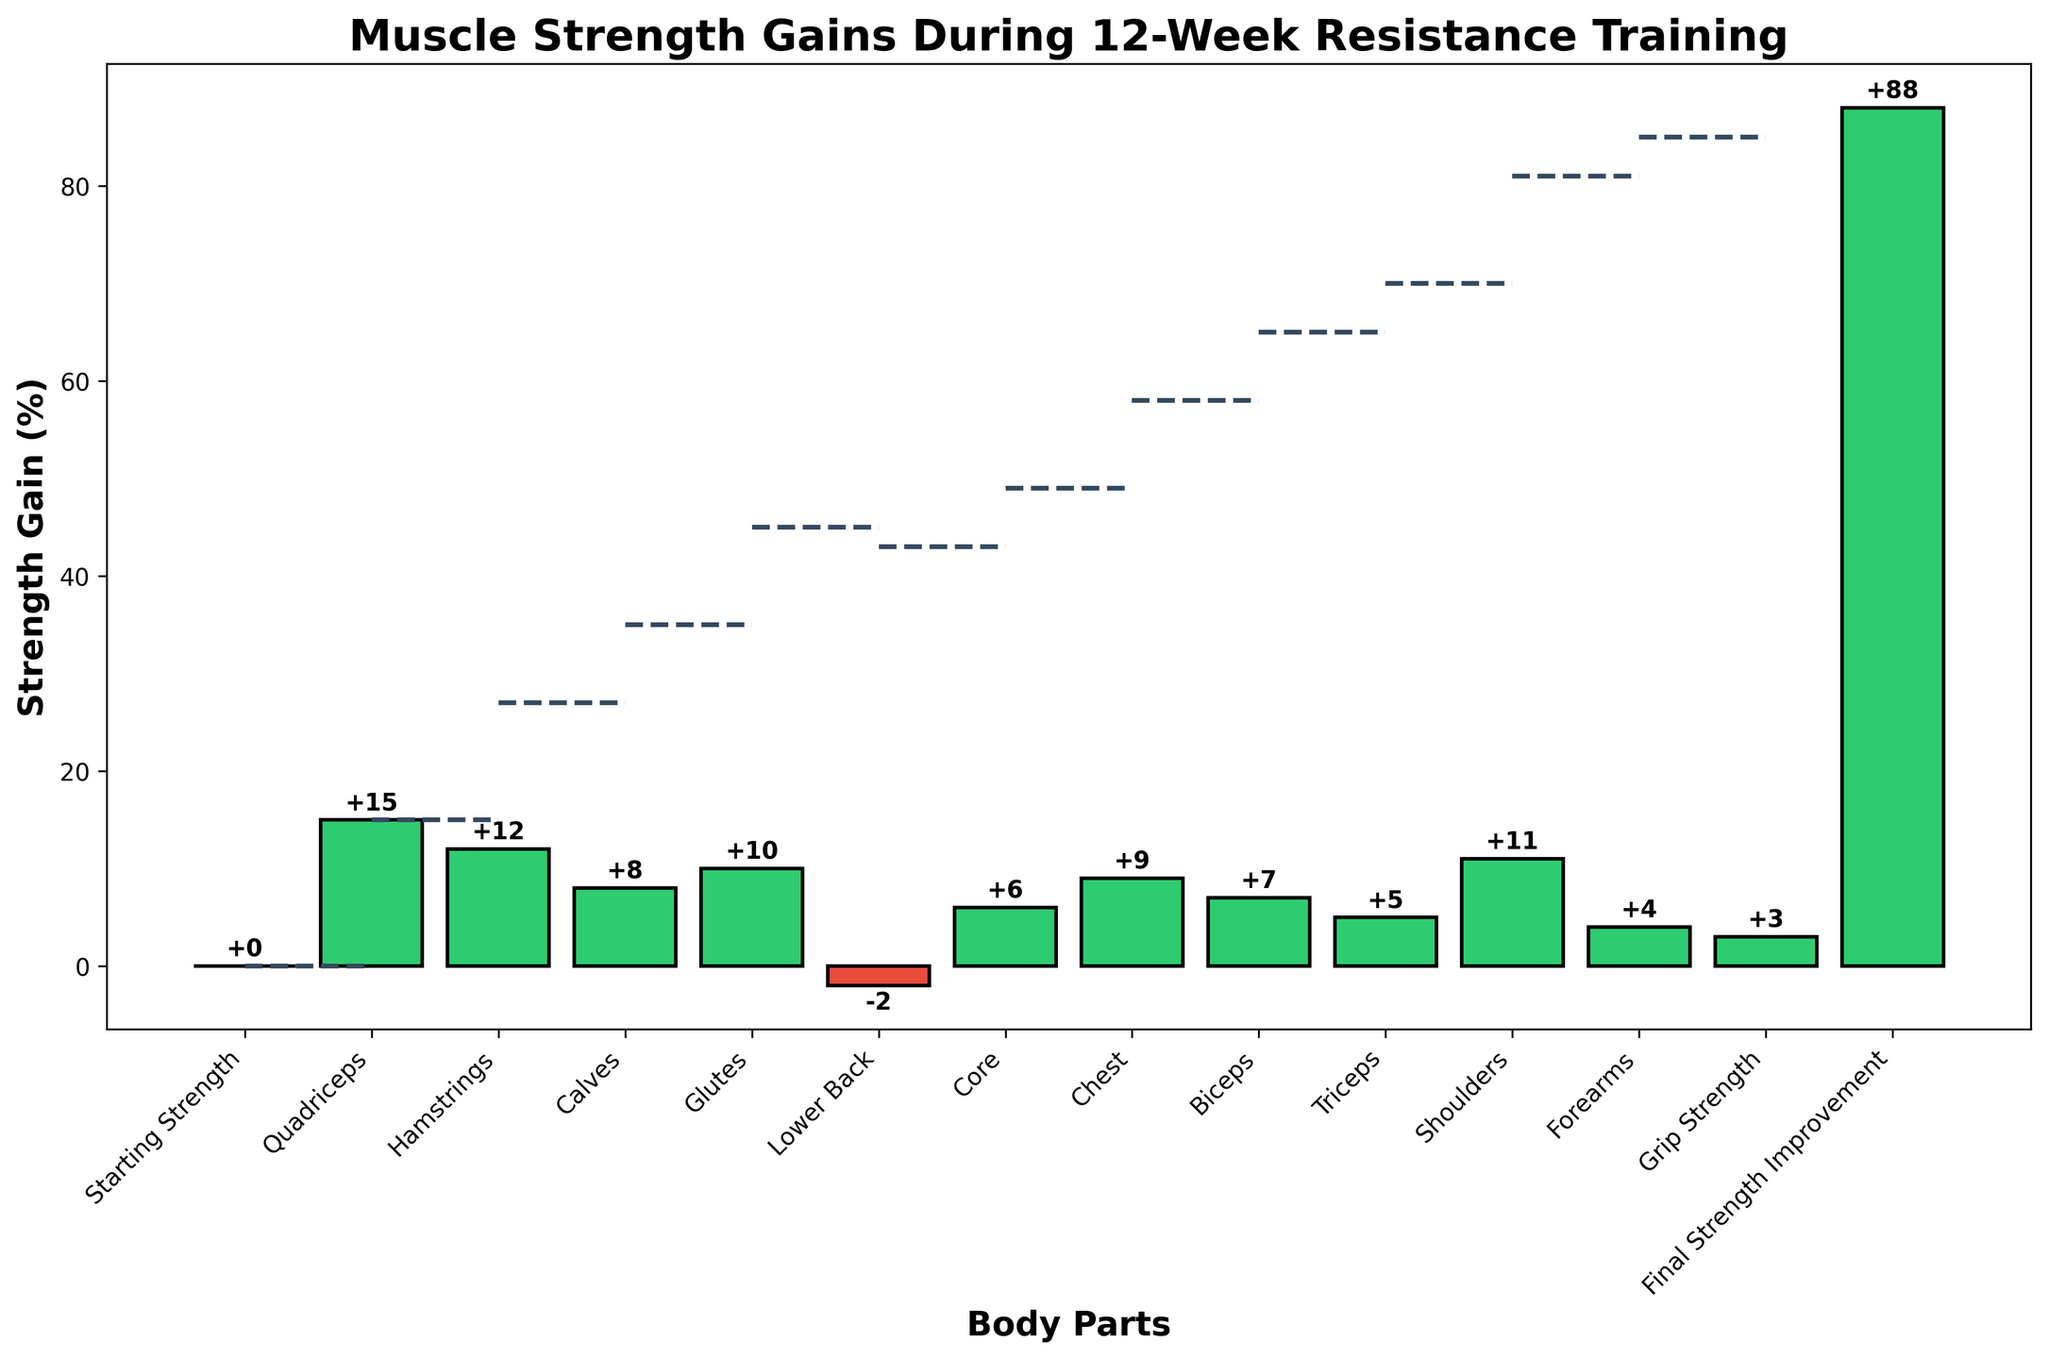What is the total strength gain improvement at the end of the 12 weeks? According to the final bar labeled "Final Strength Improvement," the total strength gain improvement at the end of the 12 weeks is +88%.
Answer: +88% Which muscle group shows the highest percentage gain in strength? By observing the heights of the bars, we see that the "Quadriceps" group has the highest percentage gain with a value of +15%.
Answer: Quadriceps What do the dashed lines in the chart represent? The dashed lines connect the cumulative gains between categories, showing how much the strength gains build up from one body part to the next.
Answer: Cumulative gains Is there any muscle group that experienced a decrease in strength? The "Lower Back" muscle group has a negative value of -2%, indicating a decrease in strength.
Answer: Lower Back How many muscle groups show a positive change in strength? By counting the number of bars with positive values, we find that there are 11 muscle groups with positive changes in strength (Quadriceps, Hamstrings, Calves, Glutes, Core, Chest, Biceps, Triceps, Shoulders, Forearms, and Grip Strength).
Answer: 11 Which muscle group experienced the smallest positive improvement in strength? By comparing the values, the "Grip Strength" muscle group shows the smallest positive improvement with a value of +3%.
Answer: Grip Strength What is the difference in strength gain between the "Quadriceps" and "Hamstrings"? The "Quadriceps" gained +15%, and the "Hamstrings" gained +12%. The difference between them is 15% - 12% = 3%.
Answer: 3% How much total strength gain is contributed by the upper body muscle groups? Summing the gains from upper body muscle groups (Chest, Biceps, Triceps, Shoulders, Forearms) gives us +9% + 7% + 5% + 11% + 4%, which totals to 36%.
Answer: 36% Which muscle groups gained more strength than the "Glutes"? By comparing the values, the muscle groups that gained more than +10% (Glutes) are "Quadriceps" (+15%), "Hamstrings" (+12%), and "Shoulders" (+11%).
Answer: Quadriceps, Hamstrings, Shoulders What's the average strength gain for the lower body muscle groups? The lower body muscle groups are Quadriceps (+15%), Hamstrings (+12%), Calves (+8%), and Glutes (+10%). The sum of their gains is 15% + 12% + 8% + 10% = 45%. The average is 45% / 4 = 11.25%.
Answer: 11.25% 